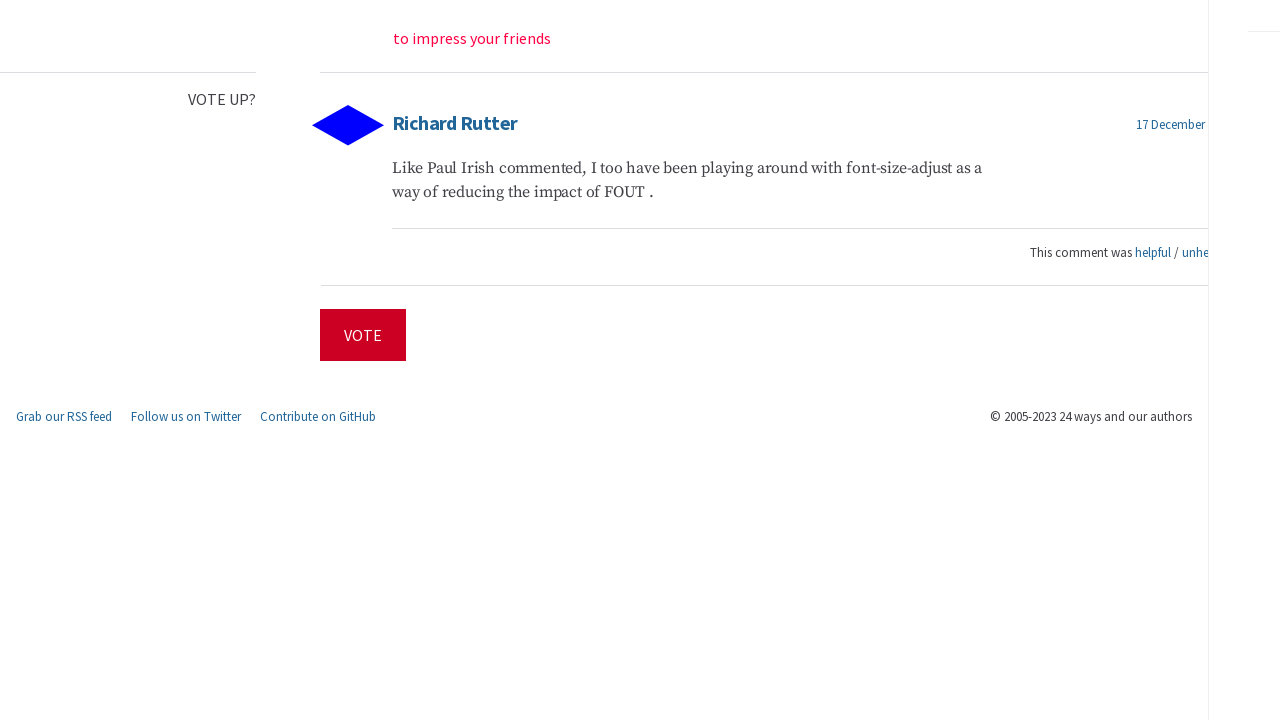What design principles were considered in constructing this web interface? The web interface design in the image seems to prioritize simplicity and user engagement. Using a minimalistic approach, it features clear, easy-to-read typography and a straightforward layout that avoids unnecessary decorations. The use of color is restrained, with red as a primary action color to draw attention to interactive elements like the 'Vote' button, enhancing user interaction. 